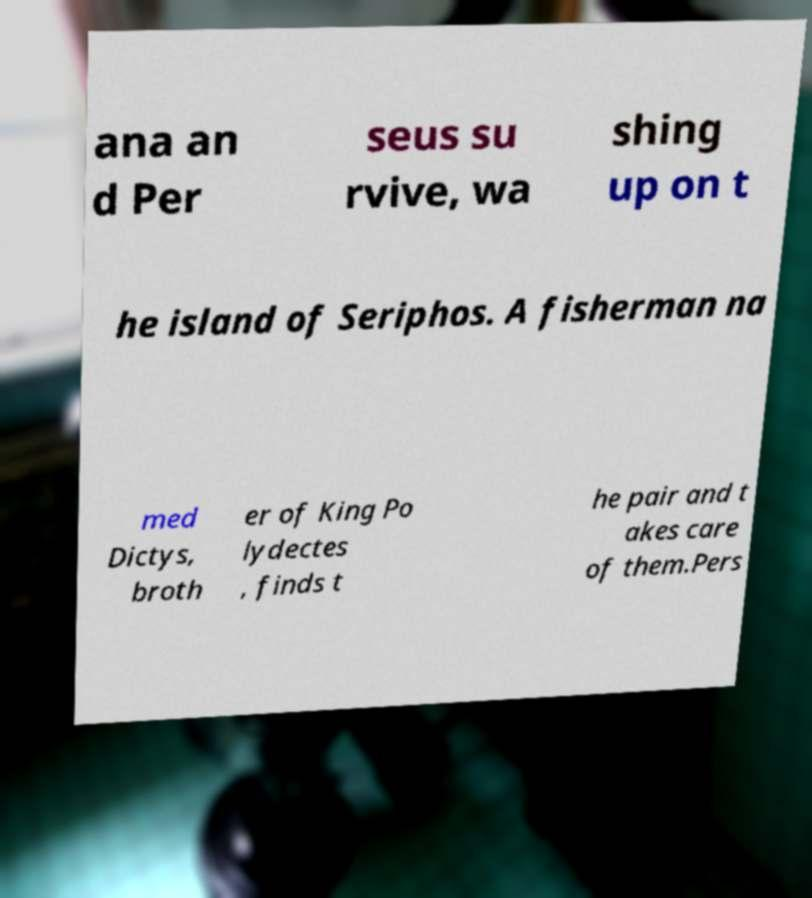For documentation purposes, I need the text within this image transcribed. Could you provide that? ana an d Per seus su rvive, wa shing up on t he island of Seriphos. A fisherman na med Dictys, broth er of King Po lydectes , finds t he pair and t akes care of them.Pers 